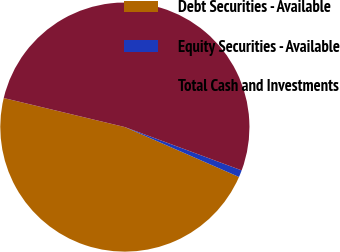<chart> <loc_0><loc_0><loc_500><loc_500><pie_chart><fcel>Debt Securities - Available<fcel>Equity Securities - Available<fcel>Total Cash and Investments<nl><fcel>47.19%<fcel>0.91%<fcel>51.91%<nl></chart> 